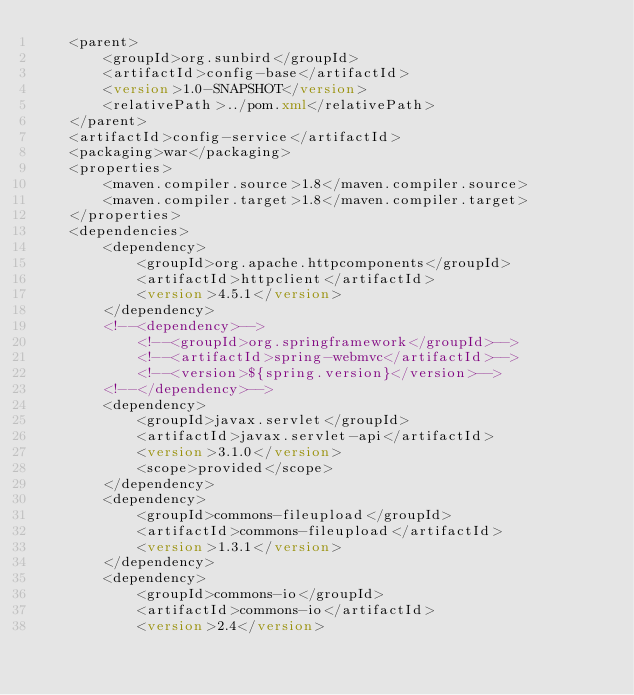Convert code to text. <code><loc_0><loc_0><loc_500><loc_500><_XML_>	<parent>
		<groupId>org.sunbird</groupId>
		<artifactId>config-base</artifactId>
		<version>1.0-SNAPSHOT</version>
		<relativePath>../pom.xml</relativePath>
	</parent>
	<artifactId>config-service</artifactId>
    <packaging>war</packaging>
	<properties>
		<maven.compiler.source>1.8</maven.compiler.source>
		<maven.compiler.target>1.8</maven.compiler.target>
	</properties>
	<dependencies>
		<dependency>
			<groupId>org.apache.httpcomponents</groupId>
			<artifactId>httpclient</artifactId>
			<version>4.5.1</version>
		</dependency>
		<!--<dependency>-->
			<!--<groupId>org.springframework</groupId>-->
			<!--<artifactId>spring-webmvc</artifactId>-->
			<!--<version>${spring.version}</version>-->
		<!--</dependency>-->
		<dependency>
			<groupId>javax.servlet</groupId>
			<artifactId>javax.servlet-api</artifactId>
			<version>3.1.0</version>
			<scope>provided</scope>
		</dependency>
		<dependency>
			<groupId>commons-fileupload</groupId>
			<artifactId>commons-fileupload</artifactId>
			<version>1.3.1</version>
		</dependency>
		<dependency>
			<groupId>commons-io</groupId>
			<artifactId>commons-io</artifactId>
			<version>2.4</version></code> 